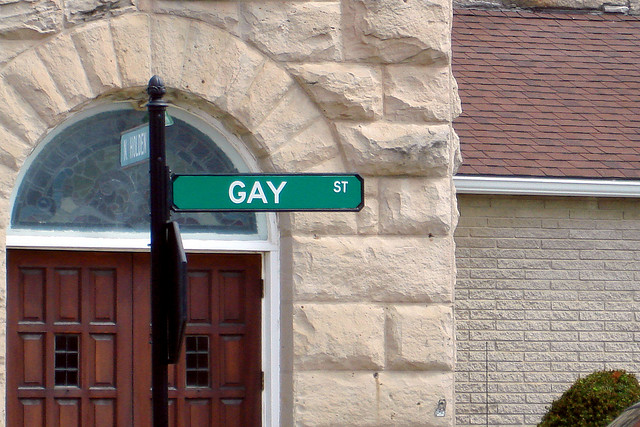<image>What is the building behind the sign? It is unclear what the building behind the sign is. It could be a church or library. What is the building behind the sign? I don't know what is the building behind the sign. It can be either a church, a library, or something else. 